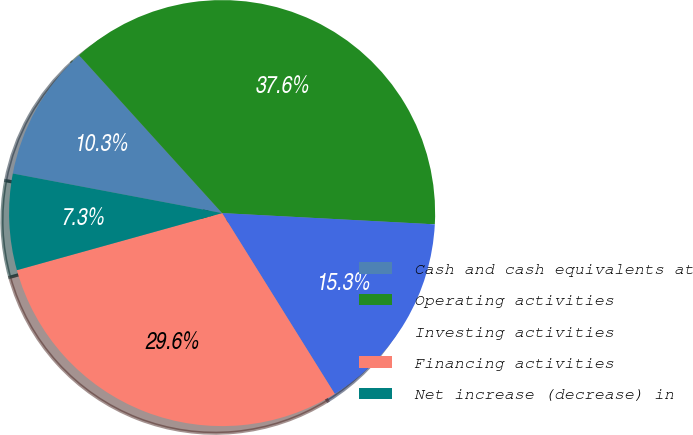<chart> <loc_0><loc_0><loc_500><loc_500><pie_chart><fcel>Cash and cash equivalents at<fcel>Operating activities<fcel>Investing activities<fcel>Financing activities<fcel>Net increase (decrease) in<nl><fcel>10.31%<fcel>37.55%<fcel>15.29%<fcel>29.55%<fcel>7.29%<nl></chart> 